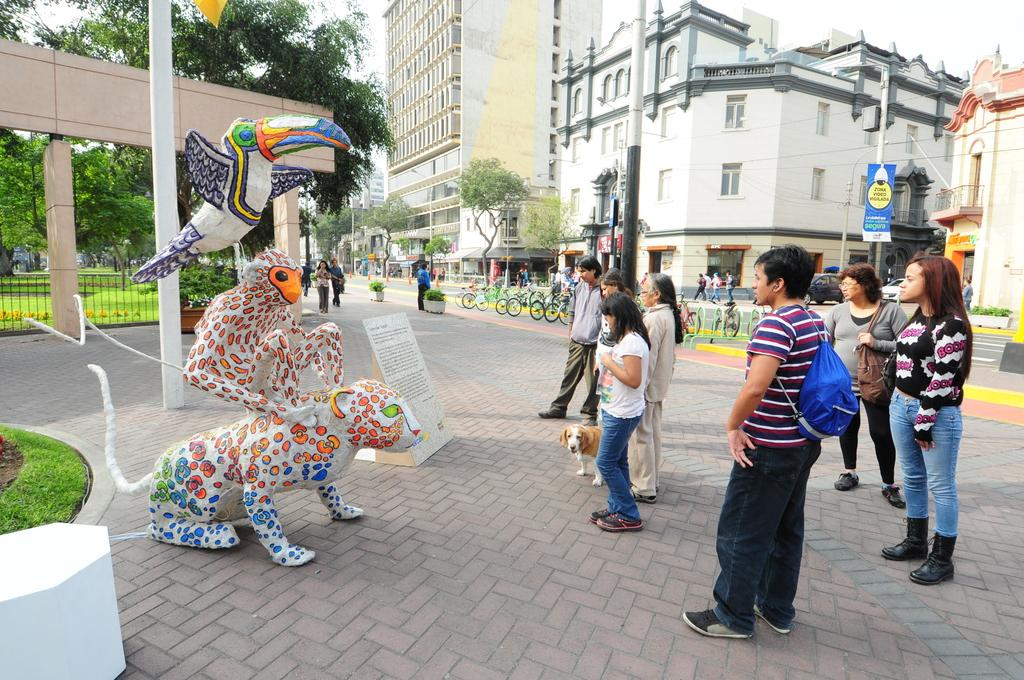What type of structures can be seen in the image? There are buildings with windows in the image. What objects are present in the image that are used for support or display? There are poles in the image. What mode of transportation can be seen in the image? There are bicycles in the image. What type of vegetation is visible in the image? There are trees, plants, and grass in the image. What type of signage is present in the image? There are boards with text in the image. What type of animal is present in the image? There is a dog in the image. What type of people are present in the image? There are people standing in the image. What type of lace can be seen on the bicycles in the image? There is no lace present on the bicycles in the image. How do the people in the image maintain their balance while standing? The people in the image are standing on solid ground, so there is no need for them to maintain their balance in a specific way. 